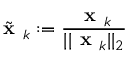<formula> <loc_0><loc_0><loc_500><loc_500>{ \tilde { x } } _ { k } \colon = { \frac { { x } _ { k } } { | | { x } _ { k } | | _ { 2 } } }</formula> 